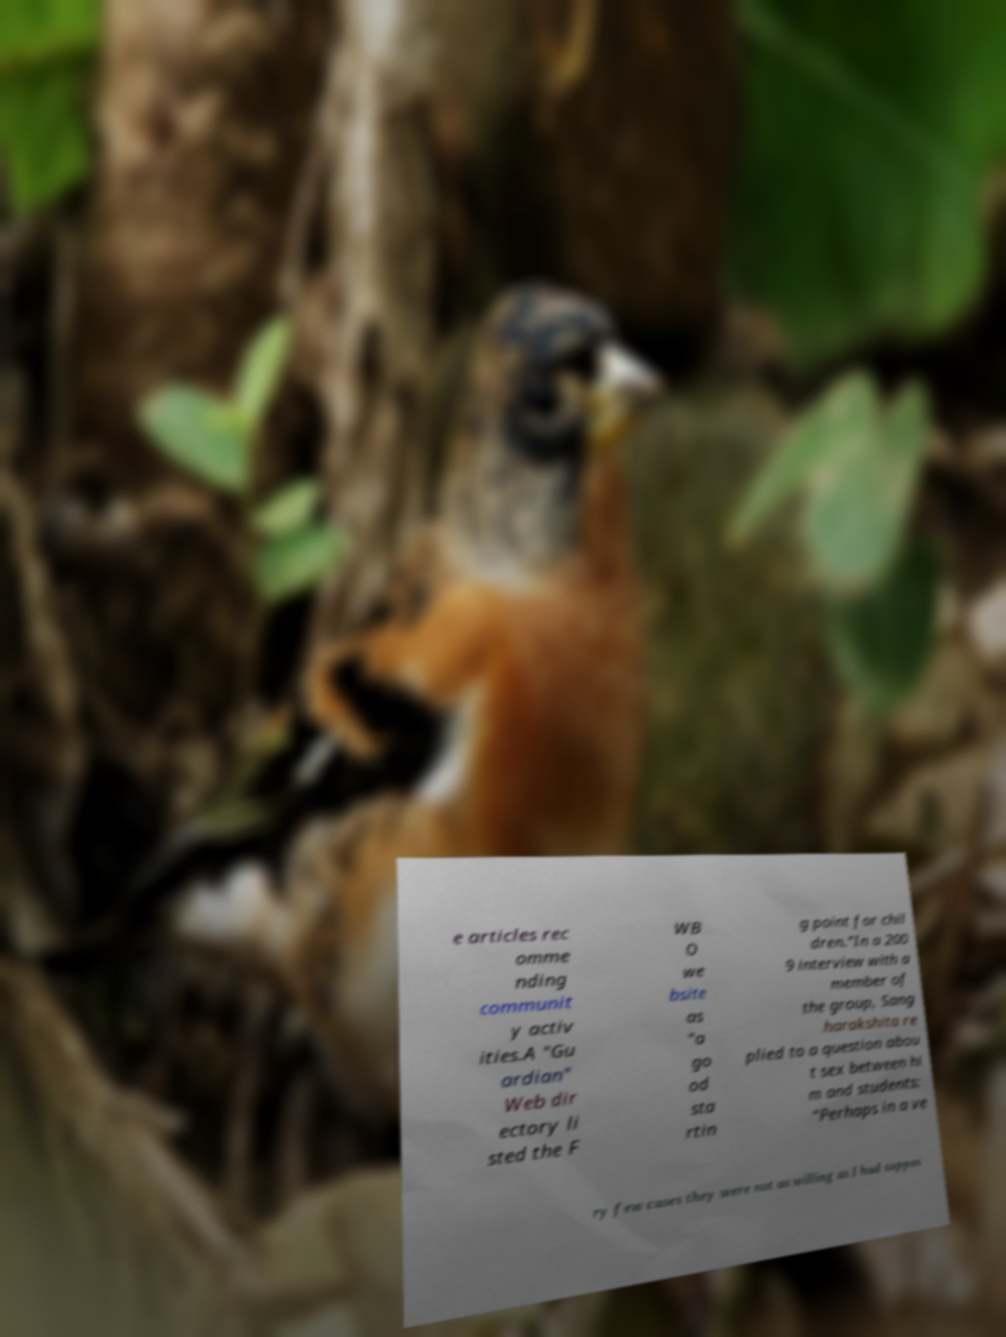Can you accurately transcribe the text from the provided image for me? e articles rec omme nding communit y activ ities.A "Gu ardian" Web dir ectory li sted the F WB O we bsite as "a go od sta rtin g point for chil dren."In a 200 9 interview with a member of the group, Sang harakshita re plied to a question abou t sex between hi m and students: “Perhaps in a ve ry few cases they were not as willing as I had suppos 